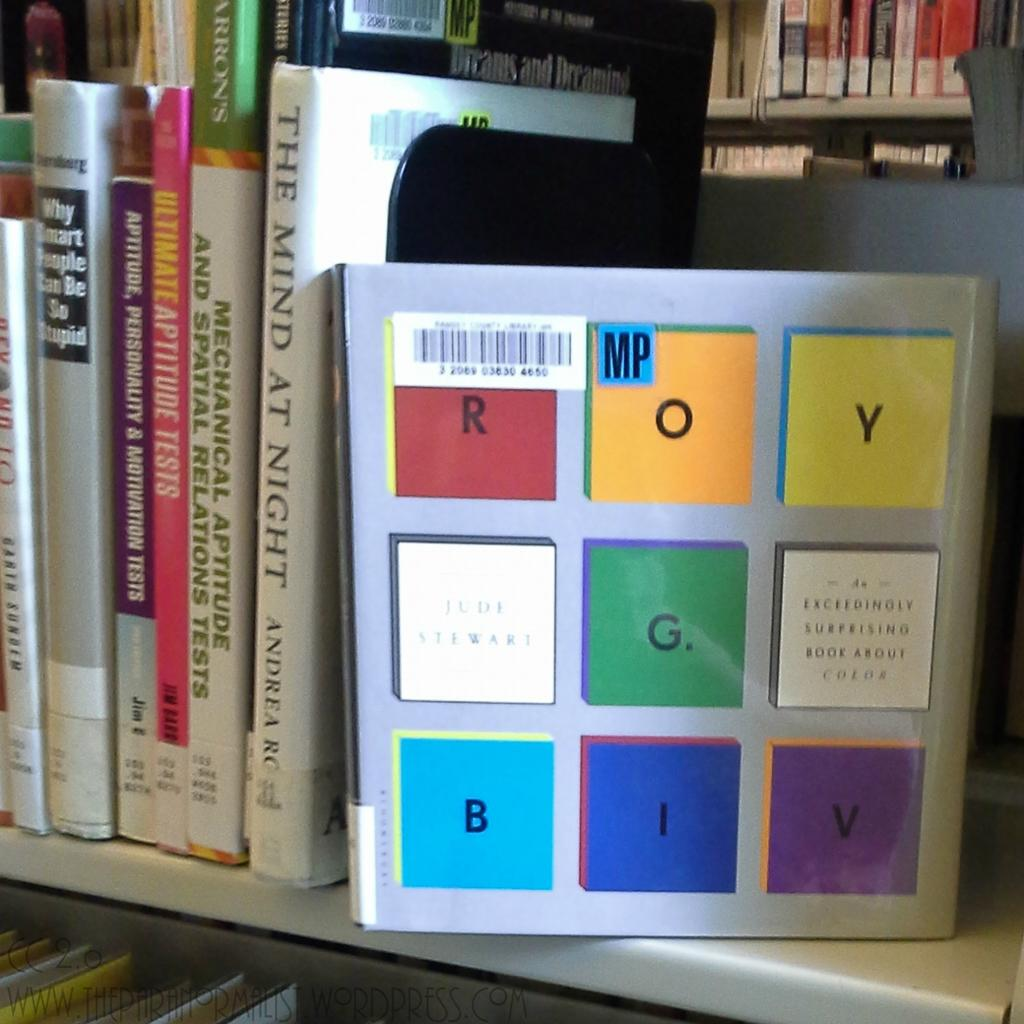Provide a one-sentence caption for the provided image. The Mind at Night, was right next to a book that was about colors. 